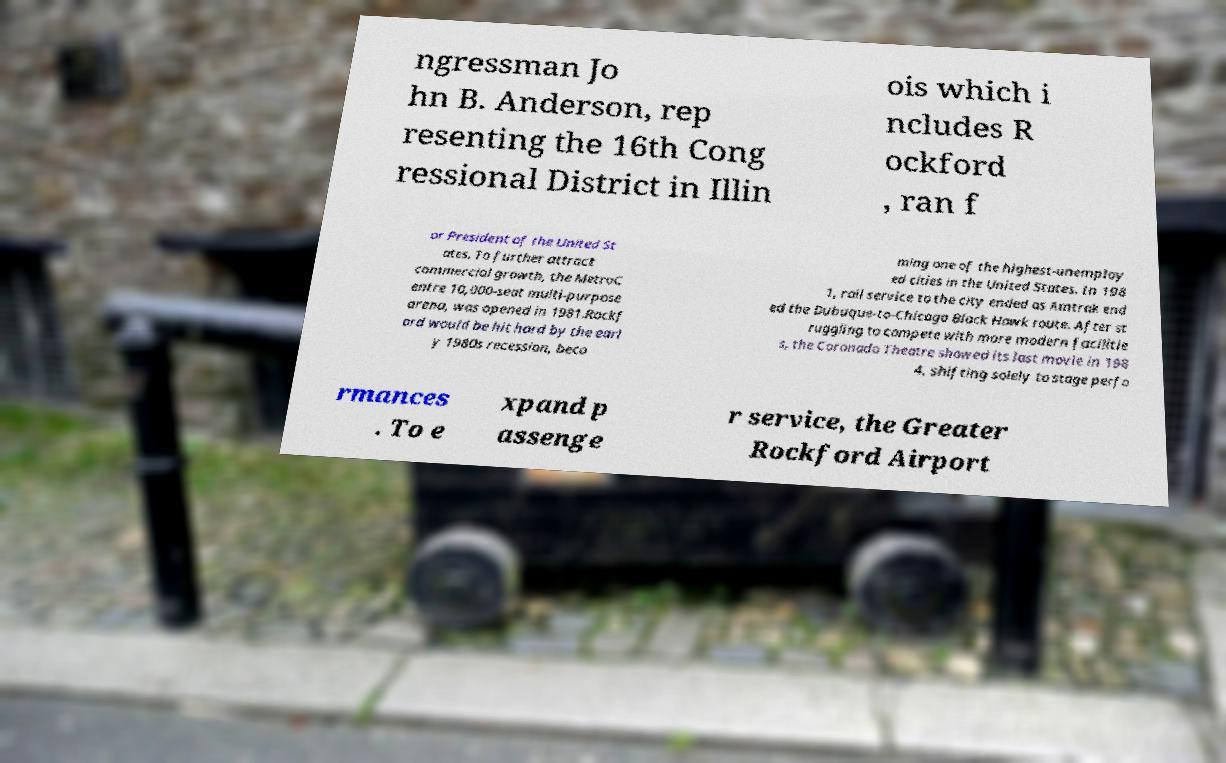For documentation purposes, I need the text within this image transcribed. Could you provide that? ngressman Jo hn B. Anderson, rep resenting the 16th Cong ressional District in Illin ois which i ncludes R ockford , ran f or President of the United St ates. To further attract commercial growth, the MetroC entre 10,000-seat multi-purpose arena, was opened in 1981.Rockf ord would be hit hard by the earl y 1980s recession, beco ming one of the highest-unemploy ed cities in the United States. In 198 1, rail service to the city ended as Amtrak end ed the Dubuque-to-Chicago Black Hawk route. After st ruggling to compete with more modern facilitie s, the Coronado Theatre showed its last movie in 198 4, shifting solely to stage perfo rmances . To e xpand p assenge r service, the Greater Rockford Airport 